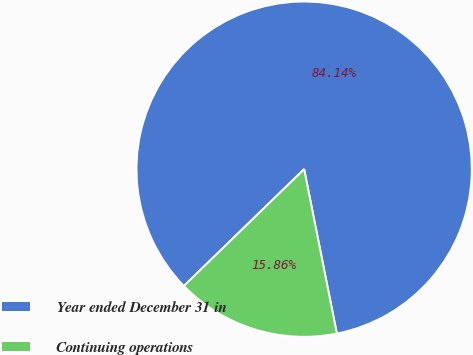<chart> <loc_0><loc_0><loc_500><loc_500><pie_chart><fcel>Year ended December 31 in<fcel>Continuing operations<nl><fcel>84.14%<fcel>15.86%<nl></chart> 